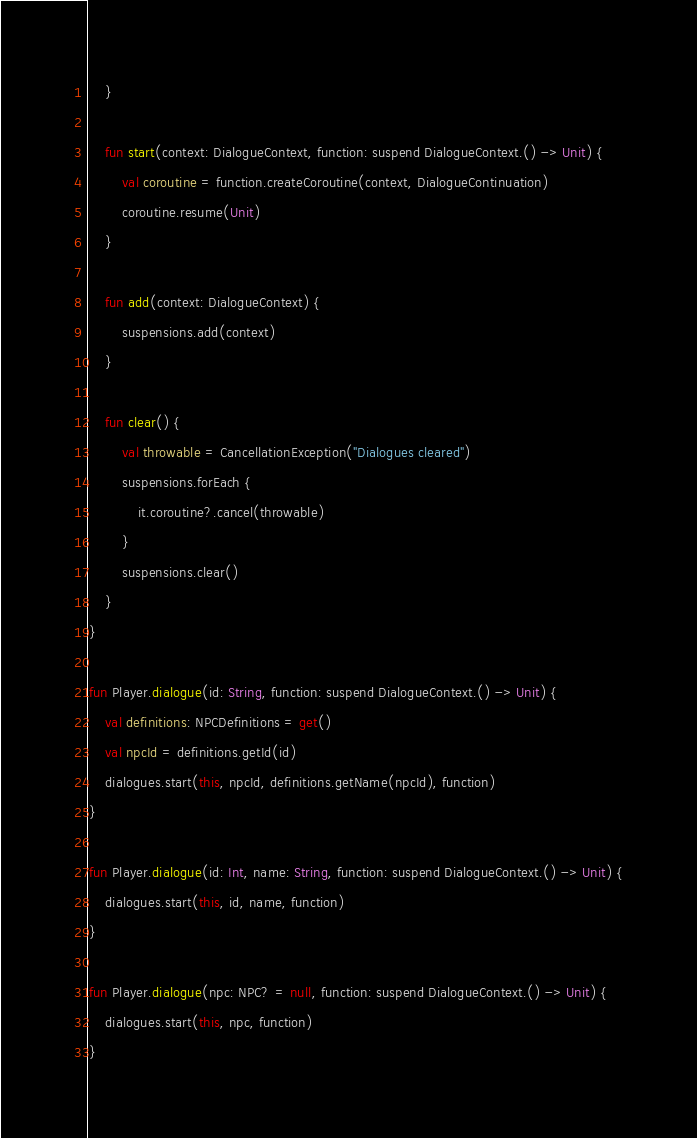<code> <loc_0><loc_0><loc_500><loc_500><_Kotlin_>    }

    fun start(context: DialogueContext, function: suspend DialogueContext.() -> Unit) {
        val coroutine = function.createCoroutine(context, DialogueContinuation)
        coroutine.resume(Unit)
    }

    fun add(context: DialogueContext) {
        suspensions.add(context)
    }

    fun clear() {
        val throwable = CancellationException("Dialogues cleared")
        suspensions.forEach {
            it.coroutine?.cancel(throwable)
        }
        suspensions.clear()
    }
}

fun Player.dialogue(id: String, function: suspend DialogueContext.() -> Unit) {
    val definitions: NPCDefinitions = get()
    val npcId = definitions.getId(id)
    dialogues.start(this, npcId, definitions.getName(npcId), function)
}

fun Player.dialogue(id: Int, name: String, function: suspend DialogueContext.() -> Unit) {
    dialogues.start(this, id, name, function)
}

fun Player.dialogue(npc: NPC? = null, function: suspend DialogueContext.() -> Unit) {
    dialogues.start(this, npc, function)
}</code> 